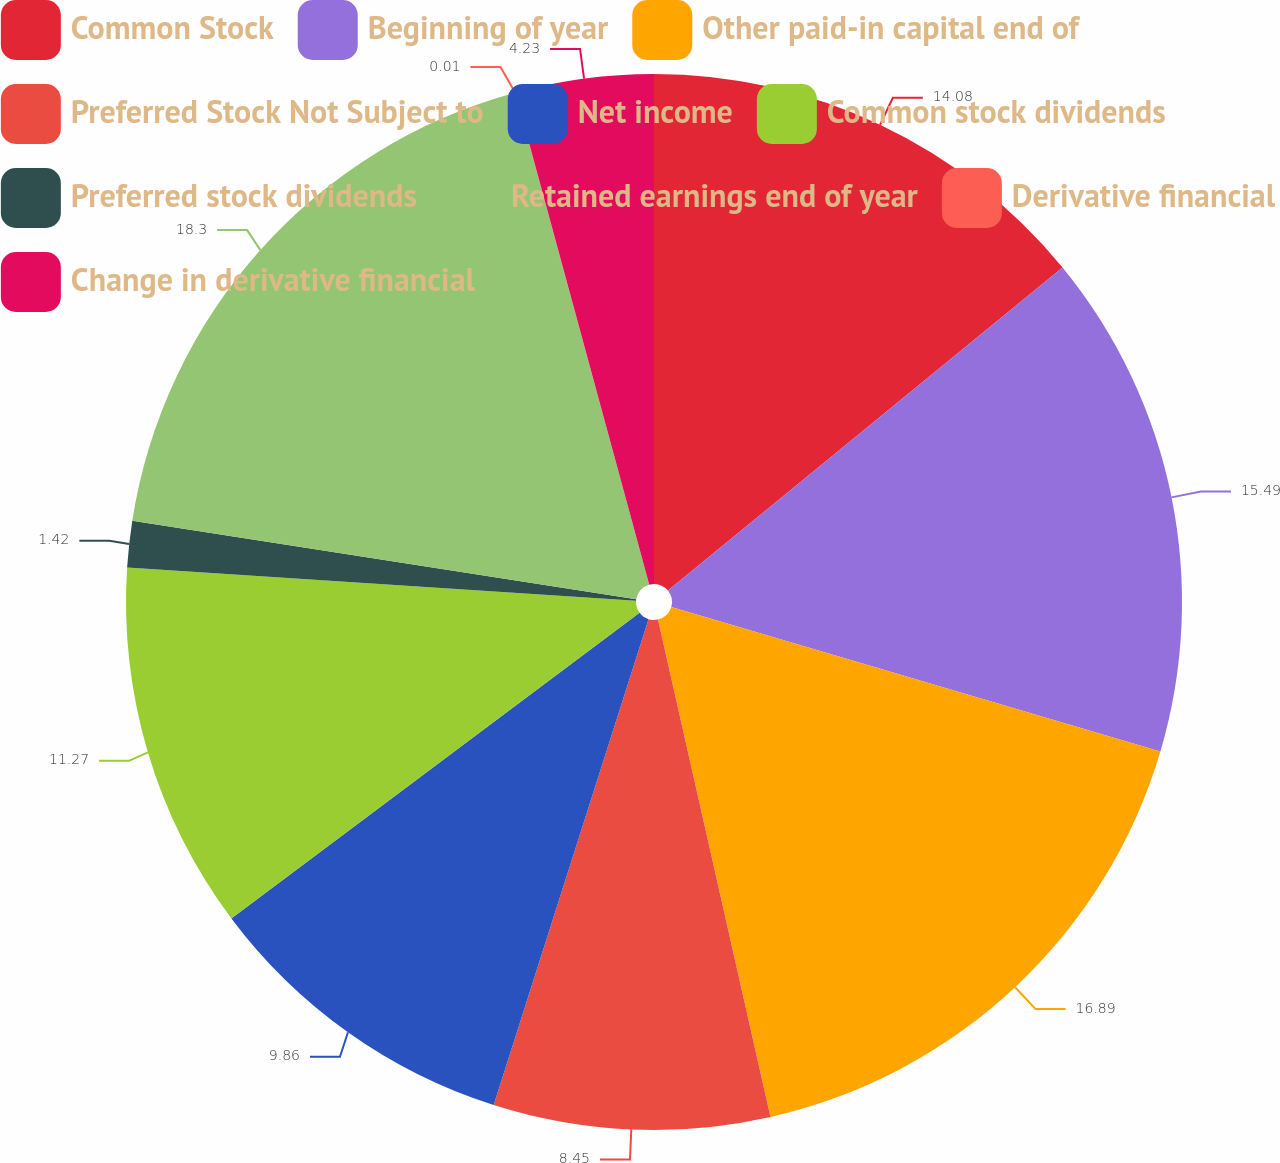Convert chart. <chart><loc_0><loc_0><loc_500><loc_500><pie_chart><fcel>Common Stock<fcel>Beginning of year<fcel>Other paid-in capital end of<fcel>Preferred Stock Not Subject to<fcel>Net income<fcel>Common stock dividends<fcel>Preferred stock dividends<fcel>Retained earnings end of year<fcel>Derivative financial<fcel>Change in derivative financial<nl><fcel>14.08%<fcel>15.49%<fcel>16.89%<fcel>8.45%<fcel>9.86%<fcel>11.27%<fcel>1.42%<fcel>18.3%<fcel>0.01%<fcel>4.23%<nl></chart> 